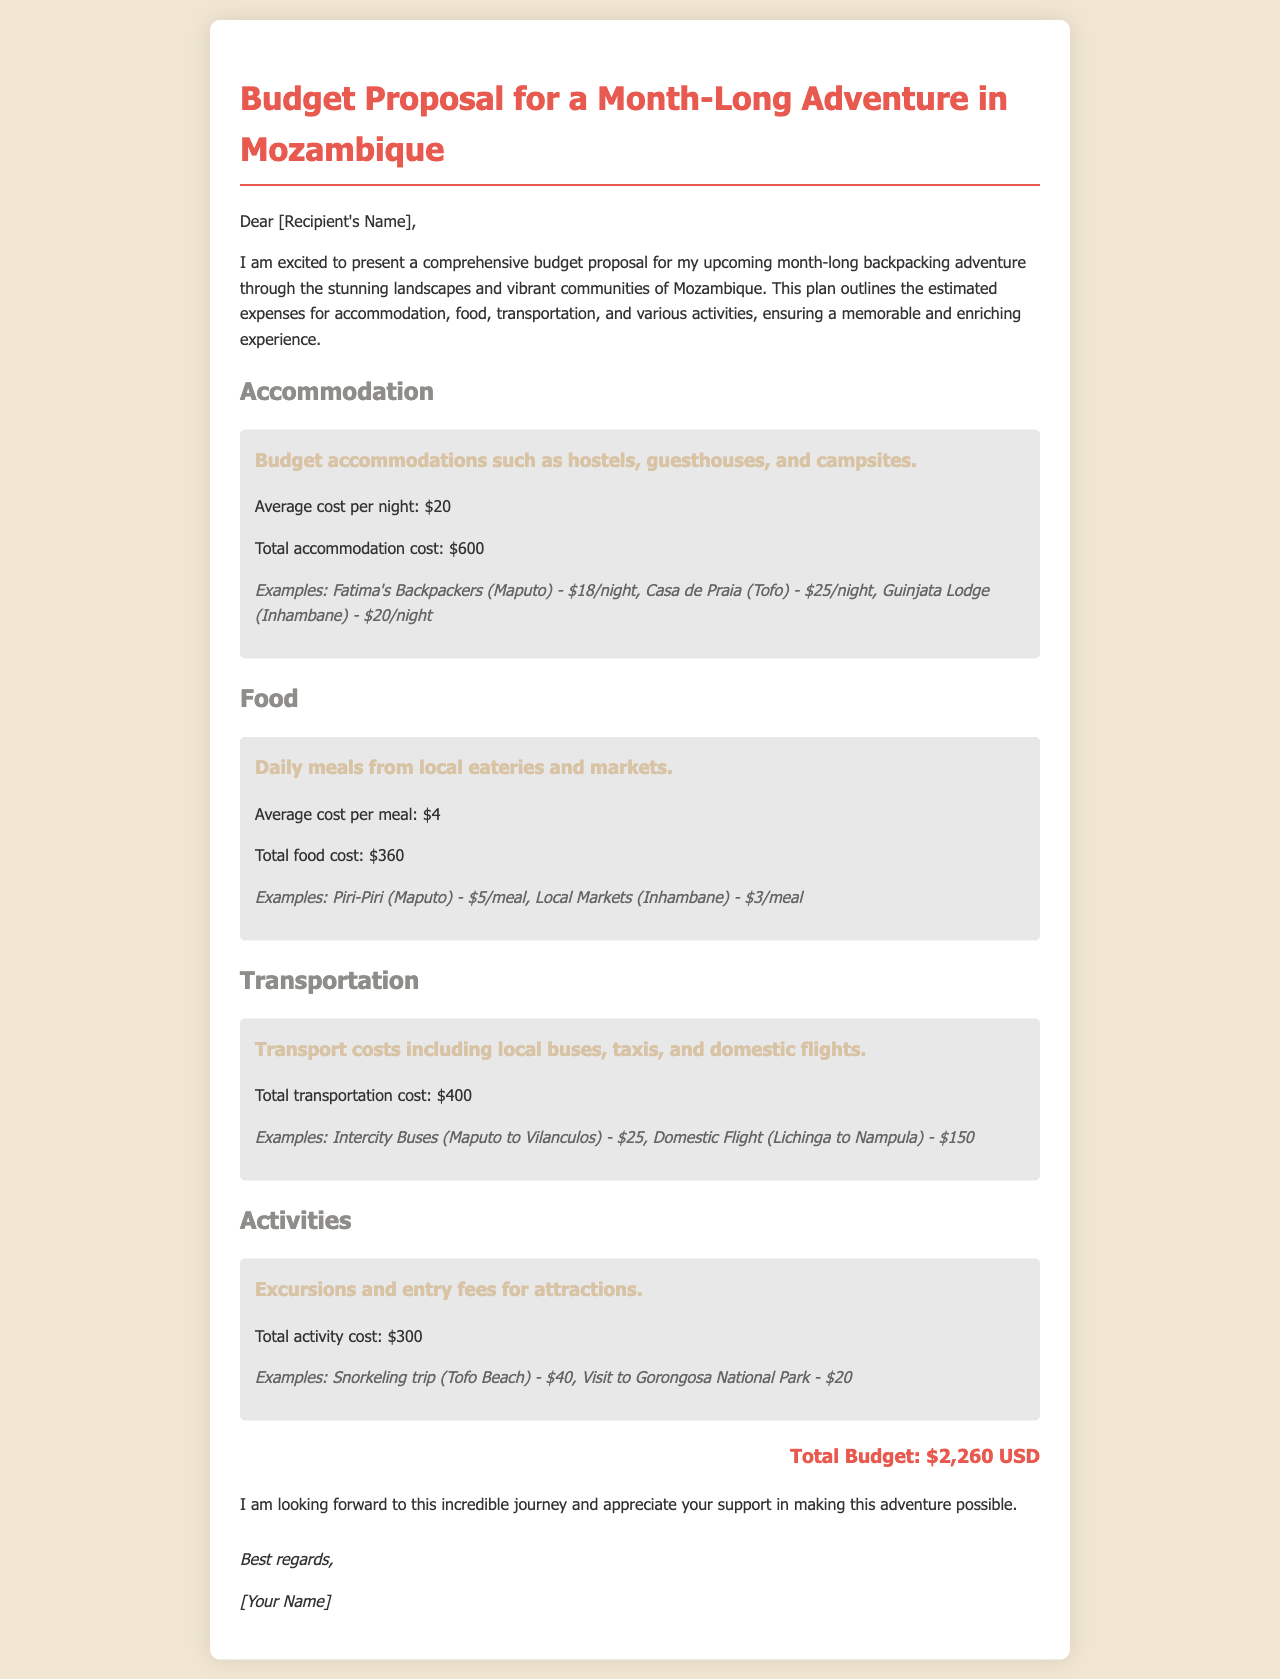What is the total accommodation cost? The total accommodation cost is specified in the document as $600.
Answer: $600 What is the average cost per meal? The average cost per meal is stated as $4 in the food section.
Answer: $4 What is the total budget for the adventure? The total budget is calculated as the sum of all expenses detailed in the document, which is $2,260 USD.
Answer: $2,260 USD What examples of accommodation are provided? The document lists specific examples of accommodations, including Fatima's Backpackers, Casa de Praia, and Guinjata Lodge.
Answer: Fatima's Backpackers, Casa de Praia, Guinjata Lodge How much does a snorkeling trip cost? The cost for the snorkeling trip is mentioned as $40 in the activities section.
Answer: $40 What form of transport is mentioned from Maputo to Vilanculos? The document mentions intercity buses as a form of transport for this route.
Answer: Intercity Buses What types of accommodation are included in the proposal? The proposal outlines budget accommodations such as hostels, guesthouses, and campsites.
Answer: Hostels, guesthouses, campsites What types of activities are budgeted for in the proposal? The document includes excursions and entry fees for attractions as the types of activities.
Answer: Excursions and entry fees 